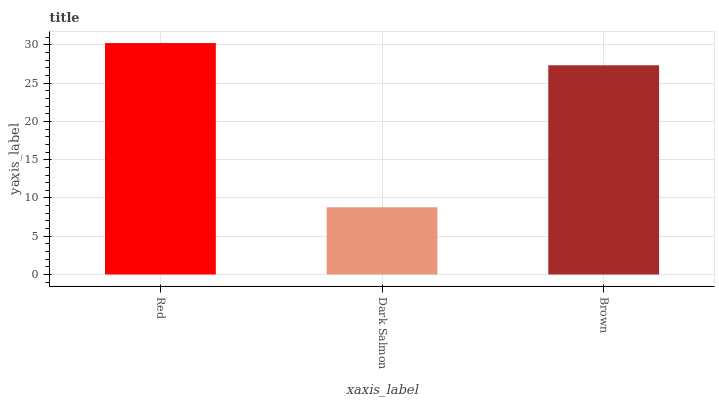Is Dark Salmon the minimum?
Answer yes or no. Yes. Is Red the maximum?
Answer yes or no. Yes. Is Brown the minimum?
Answer yes or no. No. Is Brown the maximum?
Answer yes or no. No. Is Brown greater than Dark Salmon?
Answer yes or no. Yes. Is Dark Salmon less than Brown?
Answer yes or no. Yes. Is Dark Salmon greater than Brown?
Answer yes or no. No. Is Brown less than Dark Salmon?
Answer yes or no. No. Is Brown the high median?
Answer yes or no. Yes. Is Brown the low median?
Answer yes or no. Yes. Is Red the high median?
Answer yes or no. No. Is Dark Salmon the low median?
Answer yes or no. No. 